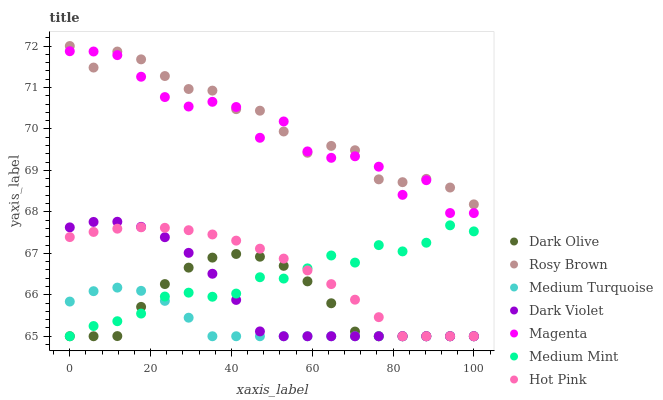Does Medium Turquoise have the minimum area under the curve?
Answer yes or no. Yes. Does Rosy Brown have the maximum area under the curve?
Answer yes or no. Yes. Does Dark Olive have the minimum area under the curve?
Answer yes or no. No. Does Dark Olive have the maximum area under the curve?
Answer yes or no. No. Is Hot Pink the smoothest?
Answer yes or no. Yes. Is Magenta the roughest?
Answer yes or no. Yes. Is Dark Olive the smoothest?
Answer yes or no. No. Is Dark Olive the roughest?
Answer yes or no. No. Does Medium Mint have the lowest value?
Answer yes or no. Yes. Does Rosy Brown have the lowest value?
Answer yes or no. No. Does Rosy Brown have the highest value?
Answer yes or no. Yes. Does Dark Olive have the highest value?
Answer yes or no. No. Is Medium Mint less than Magenta?
Answer yes or no. Yes. Is Rosy Brown greater than Dark Olive?
Answer yes or no. Yes. Does Hot Pink intersect Dark Olive?
Answer yes or no. Yes. Is Hot Pink less than Dark Olive?
Answer yes or no. No. Is Hot Pink greater than Dark Olive?
Answer yes or no. No. Does Medium Mint intersect Magenta?
Answer yes or no. No. 